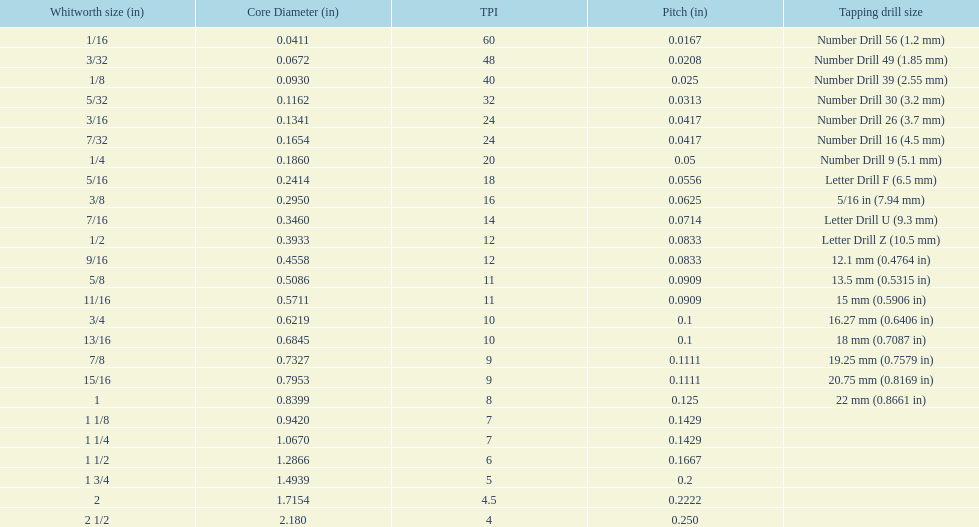How many threads per inch does a 9/16 have? 12. 